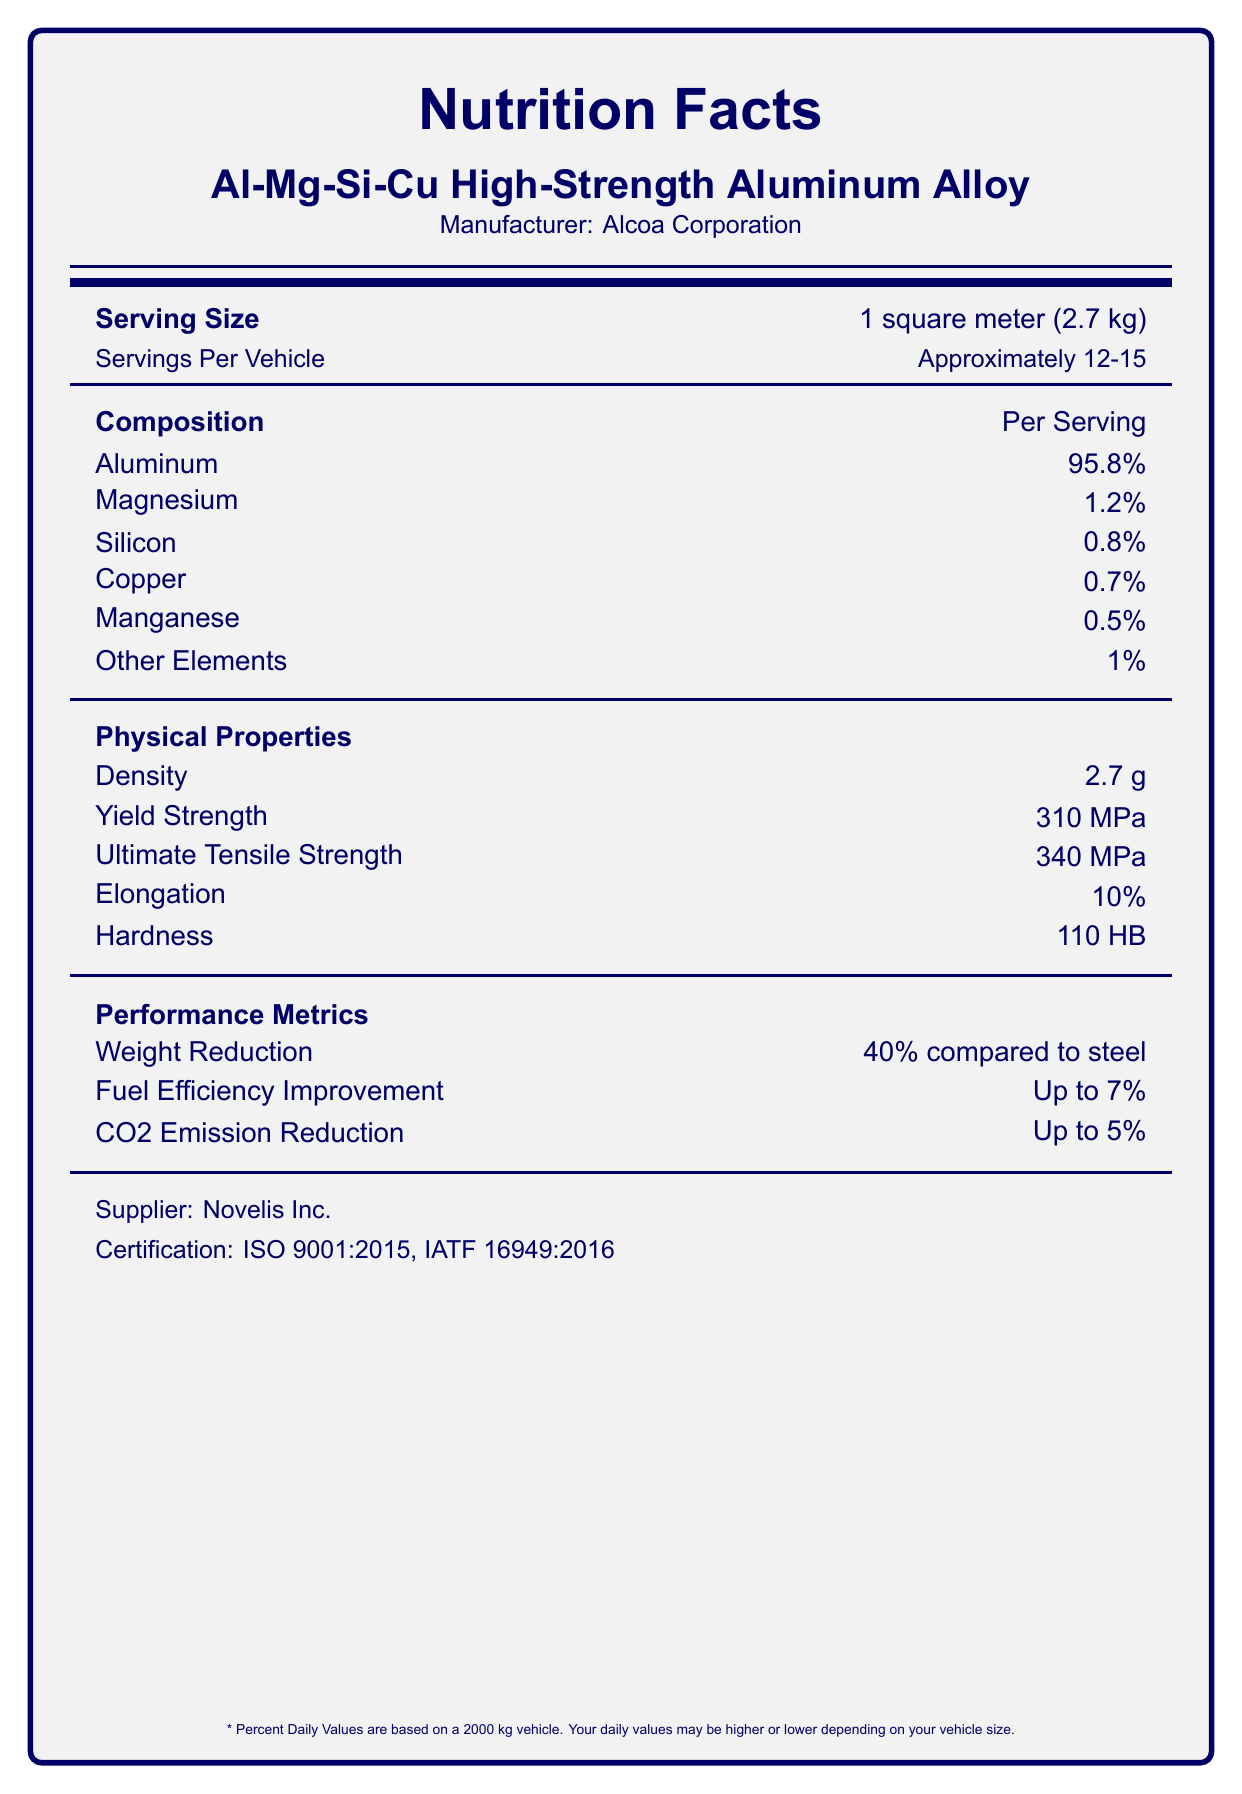what is the yield strength of the alloy? The yield strength is mentioned under the "Physical Properties" section in the document and is listed as 310 MPa.
Answer: 310 MPa how much weight reduction does the alloy offer compared to steel? The weight reduction compared to steel is directly listed under the "Performance Metrics" section as 40%.
Answer: 40% what is the manufacturer of the Al-Mg-Si-Cu High-Strength Aluminum Alloy? The manufacturer's name is provided at the top of the document under the product name.
Answer: Alcoa Corporation what is the density of the alloy? The density of the alloy is listed under the "Physical Properties" section as 2.7 g/cm³.
Answer: 2.7 g/cm³ how many meters does one serving cover? Under the "Serving Size," it states that one serving size is 1 square meter (2.7 kg).
Answer: 1 square meter How many percent of Silicon is in the alloy? The "Composition" section lists the silicon content as 0.8%.
Answer: 0.8% compared to carbon fiber, how much cost is saved by using this alloy? The "Cost Comparison" section notes that the alloy costs 60% less than carbon fiber.
Answer: 60% which of the following is included in the recycling information of the alloy? A. 50% Recyclability B. 100% Recyclability C. 80% Recyclability D. 90% Recyclability The recycling information under the "Recycling" section shows that the alloy has 100% recyclability.
Answer: B What is the ultimate tensile strength of the alloy? The ultimate tensile strength is listed as 340 MPa under the "Physical Properties" section.
Answer: 340 MPa What certification does the supplier of the alloy hold? The certification information is at the bottom of the document; the supplier holds ISO 9001:2015 and IATF 16949:2016 certifications.
Answer: ISO 9001:2015, IATF 16949:2016 The bauxite mining requirement for producing the alloy is high. True or False? The "Environmental Impact" section indicates that 4 tons of bauxite are needed per ton of alloy, which is relatively high.
Answer: True What is the exact amount of manganese found in the alloy? The composition section lists manganese as 0.5%.
Answer: 0.5% Which is correct about the alloy's environmental impact? i. Water Usage: 15 m³/ton ii. Production Energy: 170 MJ/kg iii. CO2 Emission Reduction: Up to 10% The document specifies that the production energy is 170 MJ/kg. Water usage is 10 m³/ton, not 15 m³/ton, and CO2 emission reduction is up to 5%, not 10%.
Answer: ii How is the alloy primarily manufactured? A. Hot Rolling B. Continuous Casting C. Solution Heat Treatment D. Mechanical Fastening The primary manufacturing process listed is Continuous Casting, which falls under the "Manufacturing Process" section.
Answer: B Where is the alloy commonly used in vehicles? The "Applications" section details the various parts of a vehicle where the alloy is used, including body panels like the hood and door panels, structural components like A-pillars and B-pillars, and chassis parts such as subframes and control arms.
Answer: Hood, Roof, Door Panels, A-pillars, B-pillars, Subframes, Control Arms What percentage of composition do "Other Elements" contribute to the alloy? The document mentions under the "Composition" section that Other Elements make up 1% of the alloy.
Answer: 1% Can you determine the cost per kilogram of the alloy? The document does not provide any specific price or cost per kilogram, thus making it impossible to determine this information from the given details.
Answer: Cannot be determined What is the percentage elongation of the alloy? The elongation is specified as 10% under the "Physical Properties" section.
Answer: 10% 